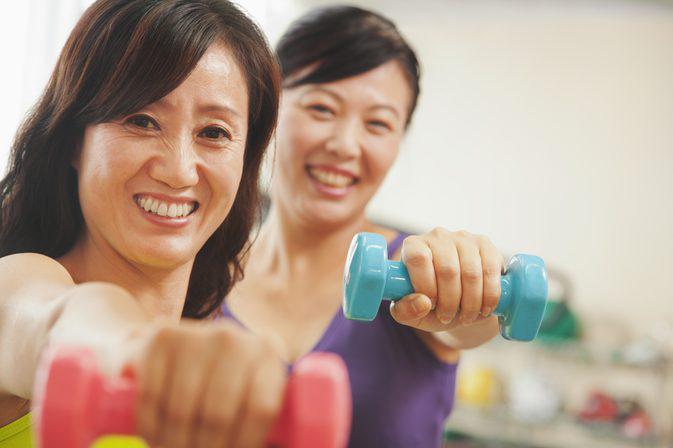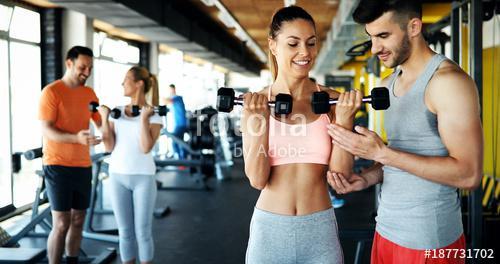The first image is the image on the left, the second image is the image on the right. For the images displayed, is the sentence "Nine or fewer humans are visible." factually correct? Answer yes or no. Yes. The first image is the image on the left, the second image is the image on the right. Given the left and right images, does the statement "There are nine people working out." hold true? Answer yes or no. No. 